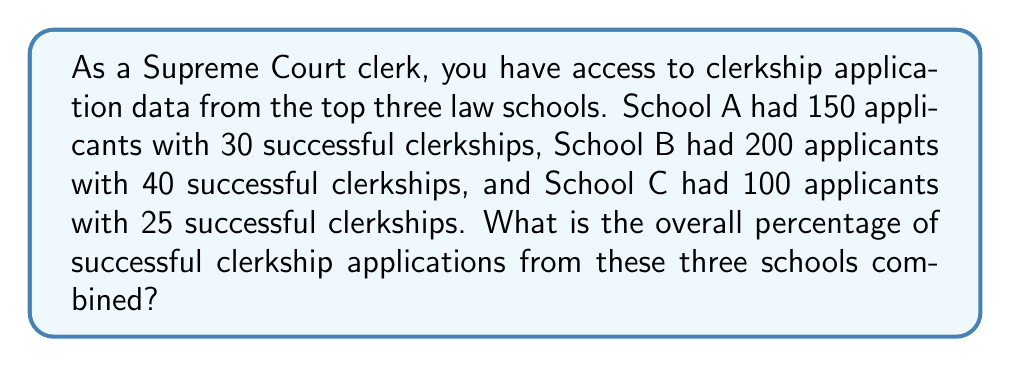Teach me how to tackle this problem. To solve this problem, we need to:

1. Calculate the total number of applicants from all three schools.
2. Calculate the total number of successful clerkships from all three schools.
3. Divide the total successful clerkships by the total applicants and convert to a percentage.

Step 1: Total applicants
$$ \text{Total applicants} = 150 + 200 + 100 = 450 $$

Step 2: Total successful clerkships
$$ \text{Total successful clerkships} = 30 + 40 + 25 = 95 $$

Step 3: Calculate the percentage
$$ \text{Percentage} = \frac{\text{Total successful clerkships}}{\text{Total applicants}} \times 100\% $$
$$ = \frac{95}{450} \times 100\% $$
$$ = 0.2111... \times 100\% $$
$$ \approx 21.11\% $$
Answer: The overall percentage of successful clerkship applications from the three schools combined is approximately 21.11%. 